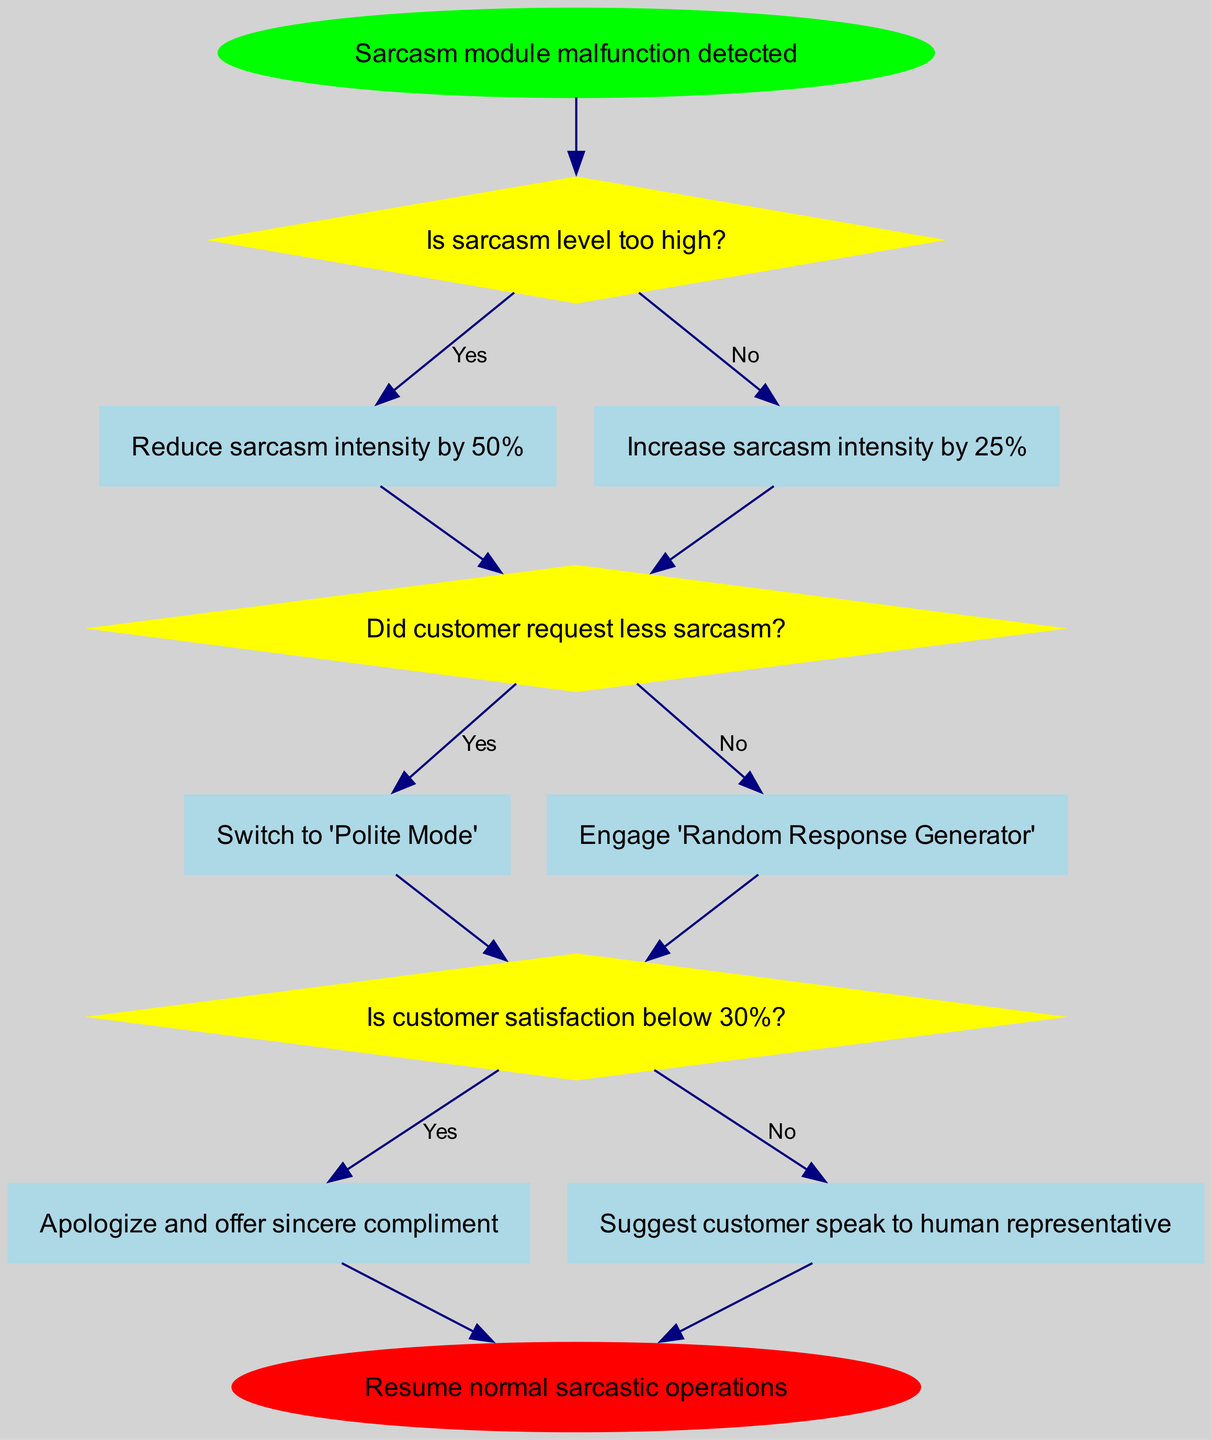What is the starting point of the flow chart? The flow chart begins with the node labeled "Sarcasm module malfunction detected." This is the initial state from which the error handling procedure begins.
Answer: Sarcasm module malfunction detected How many decision nodes are present in the diagram? The diagram contains three decision nodes: one that checks if sarcasm level is too high, another that checks if the customer requested less sarcasm, and a third that checks customer satisfaction.
Answer: 3 What action is taken if sarcasm intensity is too high? If the sarcasm level is deemed too high, the action taken is to "Reduce sarcasm intensity by 50%." This is a direct response to the decision indicating sarcasm levels.
Answer: Reduce sarcasm intensity by 50% What happens after switching to 'Polite Mode'? After switching to 'Polite Mode,' the flow continues to the next decision node to check if customer satisfaction is below 30%, as it is the subsequent action linked to that decision.
Answer: Check customer satisfaction below 30% What is the outcome if customer satisfaction is below 30%? If customer satisfaction is below 30%, the action taken is to "Apologize and offer sincere compliment," which aims to improve the customer's experience.
Answer: Apologize and offer sincere compliment What decision follows the action of engaging 'Random Response Generator'? Engaging 'Random Response Generator' leads to the next decision node, which checks if customer satisfaction is below 30%, indicating the flow's progression regardless of the previous action taken.
Answer: Check customer satisfaction below 30% What indicates a successful error handling procedure completion? The flow chart ends with the node labeled "Resume normal sarcastic operations," which signifies that the error handling procedure has been completed successfully and normal functionality can resume.
Answer: Resume normal sarcastic operations What action is taken if the customer did not request less sarcasm? If the customer did not request less sarcasm, the action taken is to "Engage 'Random Response Generator'," which suggests a shift in strategy to handle the customer's request.
Answer: Engage 'Random Response Generator' If sarcasm level is not too high, what is the next decision? If the sarcasm level is not too high, the flow proceeds to the decision titled "Did customer request less sarcasm?", continuing the handling procedure based on this new query.
Answer: Did customer request less sarcasm? 